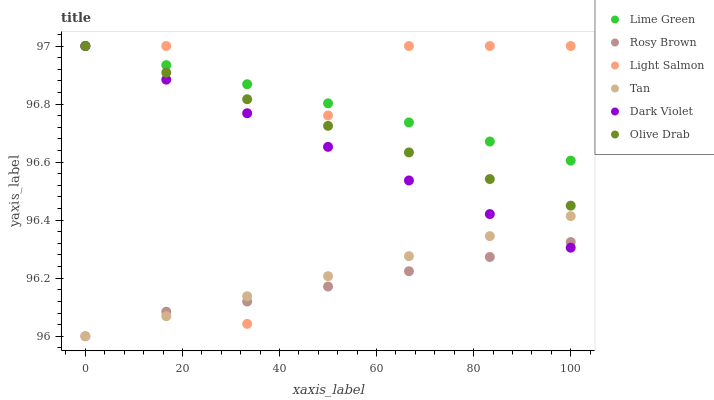Does Rosy Brown have the minimum area under the curve?
Answer yes or no. Yes. Does Lime Green have the maximum area under the curve?
Answer yes or no. Yes. Does Dark Violet have the minimum area under the curve?
Answer yes or no. No. Does Dark Violet have the maximum area under the curve?
Answer yes or no. No. Is Tan the smoothest?
Answer yes or no. Yes. Is Light Salmon the roughest?
Answer yes or no. Yes. Is Rosy Brown the smoothest?
Answer yes or no. No. Is Rosy Brown the roughest?
Answer yes or no. No. Does Rosy Brown have the lowest value?
Answer yes or no. Yes. Does Dark Violet have the lowest value?
Answer yes or no. No. Does Olive Drab have the highest value?
Answer yes or no. Yes. Does Rosy Brown have the highest value?
Answer yes or no. No. Is Rosy Brown less than Olive Drab?
Answer yes or no. Yes. Is Olive Drab greater than Tan?
Answer yes or no. Yes. Does Rosy Brown intersect Dark Violet?
Answer yes or no. Yes. Is Rosy Brown less than Dark Violet?
Answer yes or no. No. Is Rosy Brown greater than Dark Violet?
Answer yes or no. No. Does Rosy Brown intersect Olive Drab?
Answer yes or no. No. 